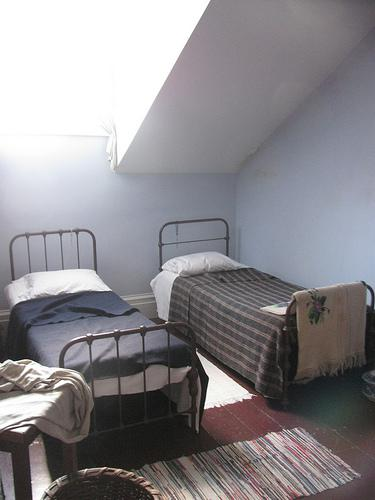Question: where was this photo taken?
Choices:
A. Bedroom.
B. Bathroom.
C. Living room.
D. Kitchen.
Answer with the letter. Answer: A Question: what are the two beds made from?
Choices:
A. Wood.
B. Particle board.
C. Plastic.
D. Metal.
Answer with the letter. Answer: D Question: what color are the pillows that are on the bed?
Choices:
A. Pink.
B. Red.
C. Green.
D. White.
Answer with the letter. Answer: D Question: who is sitting on the bed?
Choices:
A. A man.
B. No one.
C. A woman.
D. A little boy.
Answer with the letter. Answer: B 